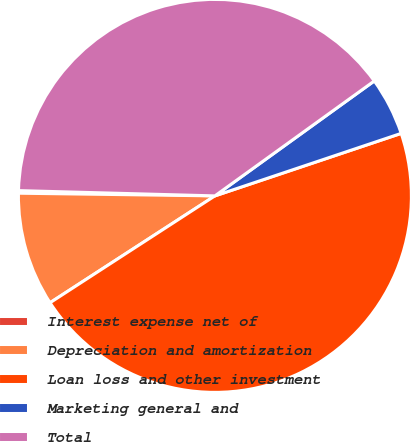<chart> <loc_0><loc_0><loc_500><loc_500><pie_chart><fcel>Interest expense net of<fcel>Depreciation and amortization<fcel>Loan loss and other investment<fcel>Marketing general and<fcel>Total<nl><fcel>0.21%<fcel>9.37%<fcel>46.0%<fcel>4.79%<fcel>39.63%<nl></chart> 